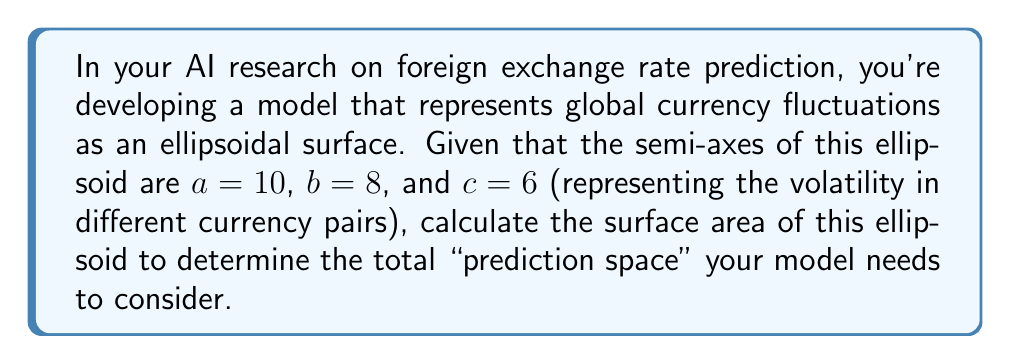Solve this math problem. To solve this problem, we'll use the approximate formula for the surface area of an ellipsoid. The exact formula involves elliptic integrals, but for practical purposes, we can use a good approximation.

The approximate formula for the surface area of an ellipsoid is:

$$S \approx 4\pi \left(\frac{(ab)^p + (ac)^p + (bc)^p}{3}\right)^{\frac{1}{p}}$$

Where $p \approx 1.6075$, and $a$, $b$, and $c$ are the semi-axes of the ellipsoid.

Let's substitute our values:
$a = 10$, $b = 8$, $c = 6$

1) First, calculate each term inside the parentheses:
   $(ab)^p = (10 \cdot 8)^{1.6075} \approx 251.7888$
   $(ac)^p = (10 \cdot 6)^{1.6075} \approx 165.9205$
   $(bc)^p = (8 \cdot 6)^{1.6075} \approx 120.8534$

2) Sum these terms and divide by 3:
   $\frac{251.7888 + 165.9205 + 120.8534}{3} \approx 179.5209$

3) Take this result to the power of $\frac{1}{p}$:
   $179.5209^{\frac{1}{1.6075}} \approx 59.2639$

4) Multiply by $4\pi$:
   $4\pi \cdot 59.2639 \approx 744.8710$

Therefore, the approximate surface area of the ellipsoid is about 744.8710 square units.
Answer: The surface area of the ellipsoid is approximately 744.87 square units. 